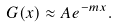Convert formula to latex. <formula><loc_0><loc_0><loc_500><loc_500>G ( x ) \approx A e ^ { - m x } .</formula> 